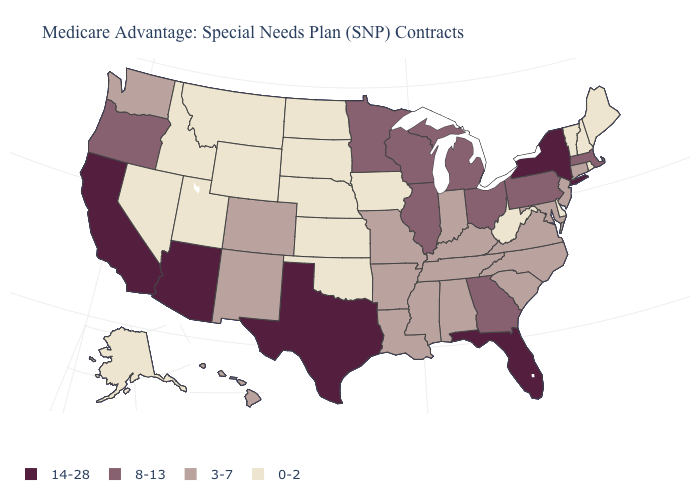Name the states that have a value in the range 0-2?
Write a very short answer. Alaska, Delaware, Iowa, Idaho, Kansas, Maine, Montana, North Dakota, Nebraska, New Hampshire, Nevada, Oklahoma, Rhode Island, South Dakota, Utah, Vermont, West Virginia, Wyoming. What is the value of Rhode Island?
Concise answer only. 0-2. Does Arizona have the highest value in the West?
Be succinct. Yes. Does New York have the highest value in the USA?
Give a very brief answer. Yes. How many symbols are there in the legend?
Quick response, please. 4. What is the value of Nebraska?
Keep it brief. 0-2. What is the lowest value in states that border South Dakota?
Answer briefly. 0-2. What is the value of Hawaii?
Keep it brief. 3-7. Name the states that have a value in the range 0-2?
Write a very short answer. Alaska, Delaware, Iowa, Idaho, Kansas, Maine, Montana, North Dakota, Nebraska, New Hampshire, Nevada, Oklahoma, Rhode Island, South Dakota, Utah, Vermont, West Virginia, Wyoming. Is the legend a continuous bar?
Short answer required. No. Does Pennsylvania have the lowest value in the Northeast?
Answer briefly. No. What is the value of Nevada?
Short answer required. 0-2. Among the states that border Idaho , does Wyoming have the highest value?
Write a very short answer. No. What is the highest value in the MidWest ?
Keep it brief. 8-13. 